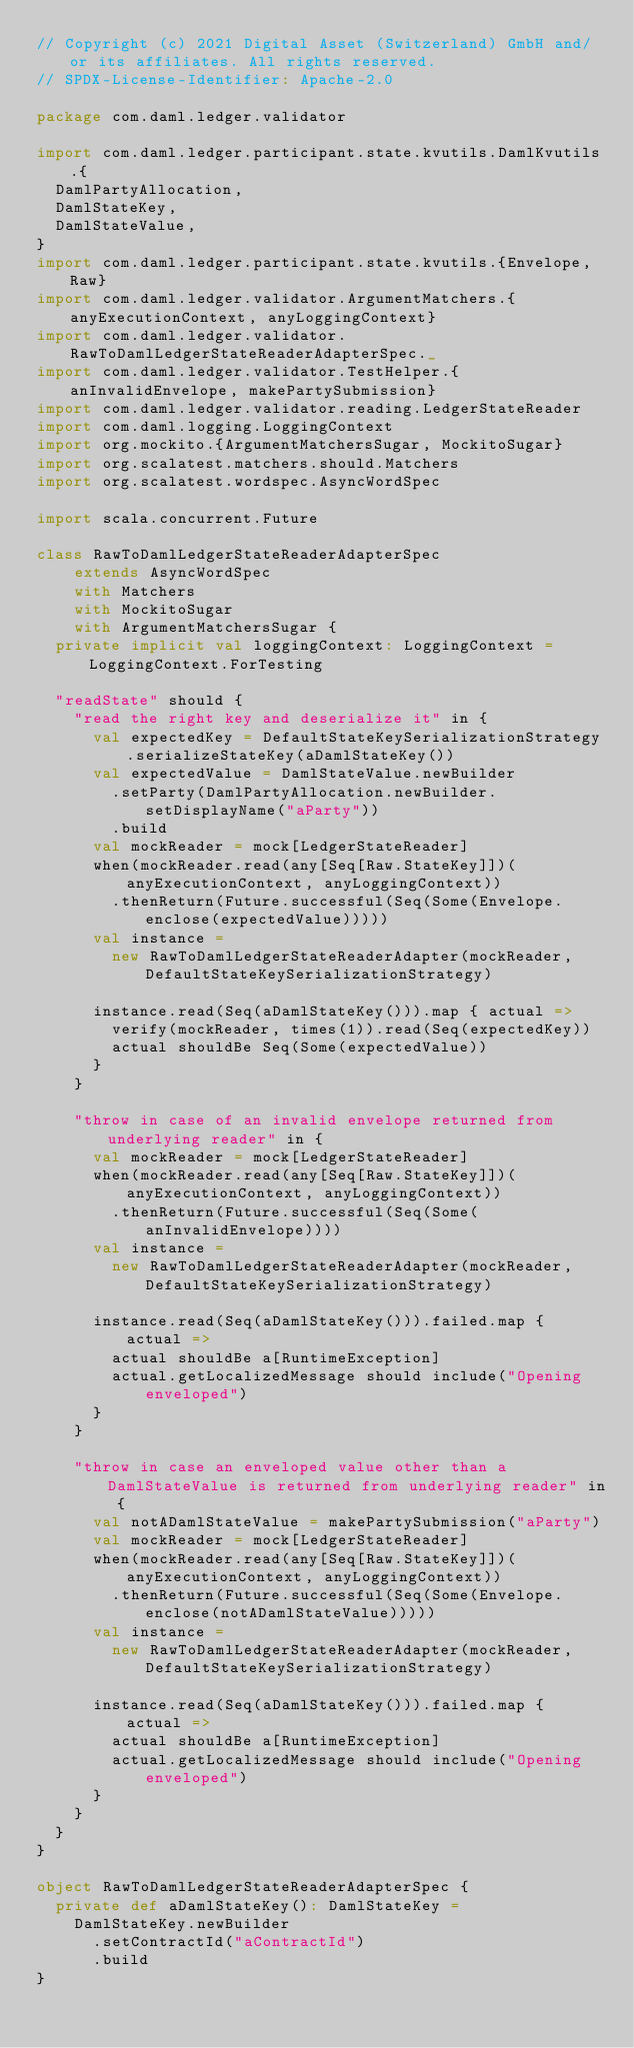<code> <loc_0><loc_0><loc_500><loc_500><_Scala_>// Copyright (c) 2021 Digital Asset (Switzerland) GmbH and/or its affiliates. All rights reserved.
// SPDX-License-Identifier: Apache-2.0

package com.daml.ledger.validator

import com.daml.ledger.participant.state.kvutils.DamlKvutils.{
  DamlPartyAllocation,
  DamlStateKey,
  DamlStateValue,
}
import com.daml.ledger.participant.state.kvutils.{Envelope, Raw}
import com.daml.ledger.validator.ArgumentMatchers.{anyExecutionContext, anyLoggingContext}
import com.daml.ledger.validator.RawToDamlLedgerStateReaderAdapterSpec._
import com.daml.ledger.validator.TestHelper.{anInvalidEnvelope, makePartySubmission}
import com.daml.ledger.validator.reading.LedgerStateReader
import com.daml.logging.LoggingContext
import org.mockito.{ArgumentMatchersSugar, MockitoSugar}
import org.scalatest.matchers.should.Matchers
import org.scalatest.wordspec.AsyncWordSpec

import scala.concurrent.Future

class RawToDamlLedgerStateReaderAdapterSpec
    extends AsyncWordSpec
    with Matchers
    with MockitoSugar
    with ArgumentMatchersSugar {
  private implicit val loggingContext: LoggingContext = LoggingContext.ForTesting

  "readState" should {
    "read the right key and deserialize it" in {
      val expectedKey = DefaultStateKeySerializationStrategy.serializeStateKey(aDamlStateKey())
      val expectedValue = DamlStateValue.newBuilder
        .setParty(DamlPartyAllocation.newBuilder.setDisplayName("aParty"))
        .build
      val mockReader = mock[LedgerStateReader]
      when(mockReader.read(any[Seq[Raw.StateKey]])(anyExecutionContext, anyLoggingContext))
        .thenReturn(Future.successful(Seq(Some(Envelope.enclose(expectedValue)))))
      val instance =
        new RawToDamlLedgerStateReaderAdapter(mockReader, DefaultStateKeySerializationStrategy)

      instance.read(Seq(aDamlStateKey())).map { actual =>
        verify(mockReader, times(1)).read(Seq(expectedKey))
        actual shouldBe Seq(Some(expectedValue))
      }
    }

    "throw in case of an invalid envelope returned from underlying reader" in {
      val mockReader = mock[LedgerStateReader]
      when(mockReader.read(any[Seq[Raw.StateKey]])(anyExecutionContext, anyLoggingContext))
        .thenReturn(Future.successful(Seq(Some(anInvalidEnvelope))))
      val instance =
        new RawToDamlLedgerStateReaderAdapter(mockReader, DefaultStateKeySerializationStrategy)

      instance.read(Seq(aDamlStateKey())).failed.map { actual =>
        actual shouldBe a[RuntimeException]
        actual.getLocalizedMessage should include("Opening enveloped")
      }
    }

    "throw in case an enveloped value other than a DamlStateValue is returned from underlying reader" in {
      val notADamlStateValue = makePartySubmission("aParty")
      val mockReader = mock[LedgerStateReader]
      when(mockReader.read(any[Seq[Raw.StateKey]])(anyExecutionContext, anyLoggingContext))
        .thenReturn(Future.successful(Seq(Some(Envelope.enclose(notADamlStateValue)))))
      val instance =
        new RawToDamlLedgerStateReaderAdapter(mockReader, DefaultStateKeySerializationStrategy)

      instance.read(Seq(aDamlStateKey())).failed.map { actual =>
        actual shouldBe a[RuntimeException]
        actual.getLocalizedMessage should include("Opening enveloped")
      }
    }
  }
}

object RawToDamlLedgerStateReaderAdapterSpec {
  private def aDamlStateKey(): DamlStateKey =
    DamlStateKey.newBuilder
      .setContractId("aContractId")
      .build
}
</code> 